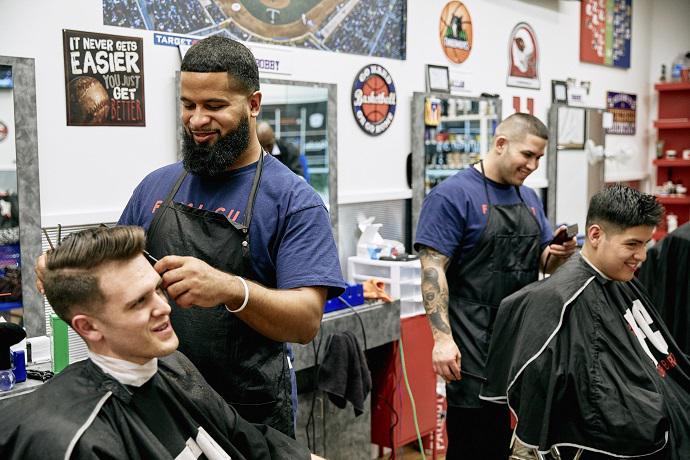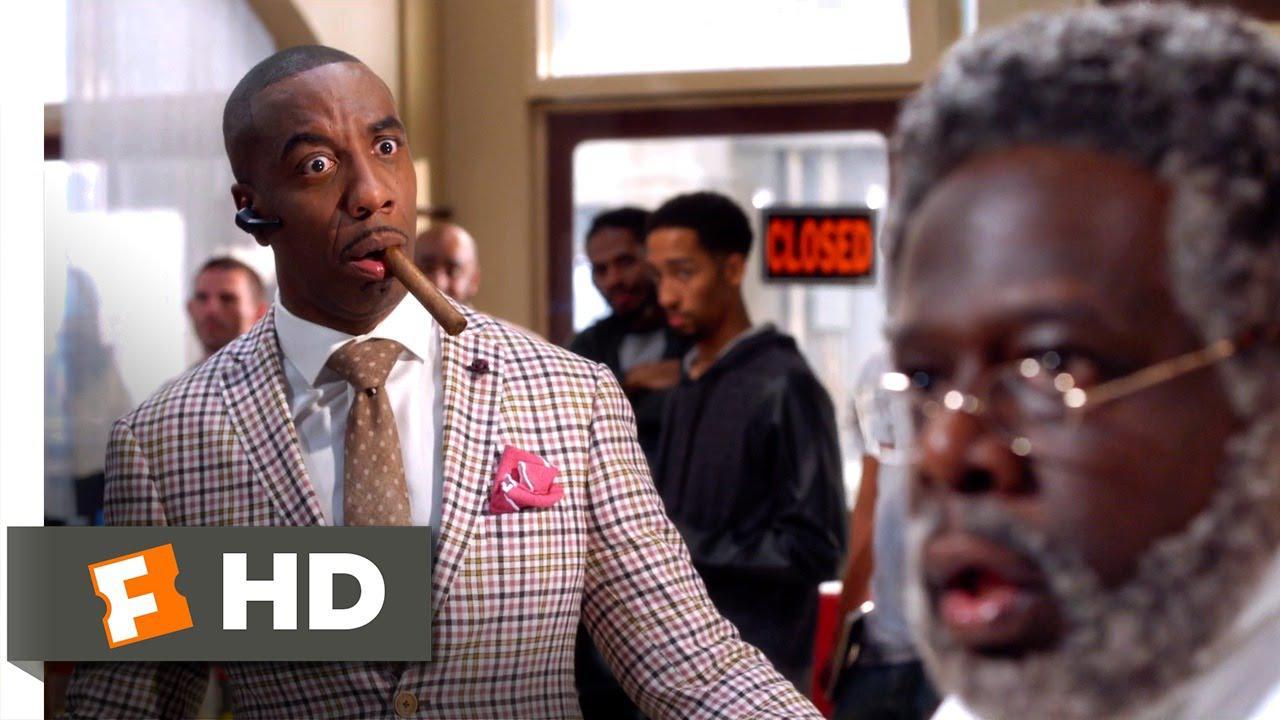The first image is the image on the left, the second image is the image on the right. Considering the images on both sides, is "In one image, a large barber shop mural is on a back wall beside a door." valid? Answer yes or no. No. The first image is the image on the left, the second image is the image on the right. Considering the images on both sides, is "An image includes a woman wearing red top and stars-and-stripes bottoms." valid? Answer yes or no. No. 